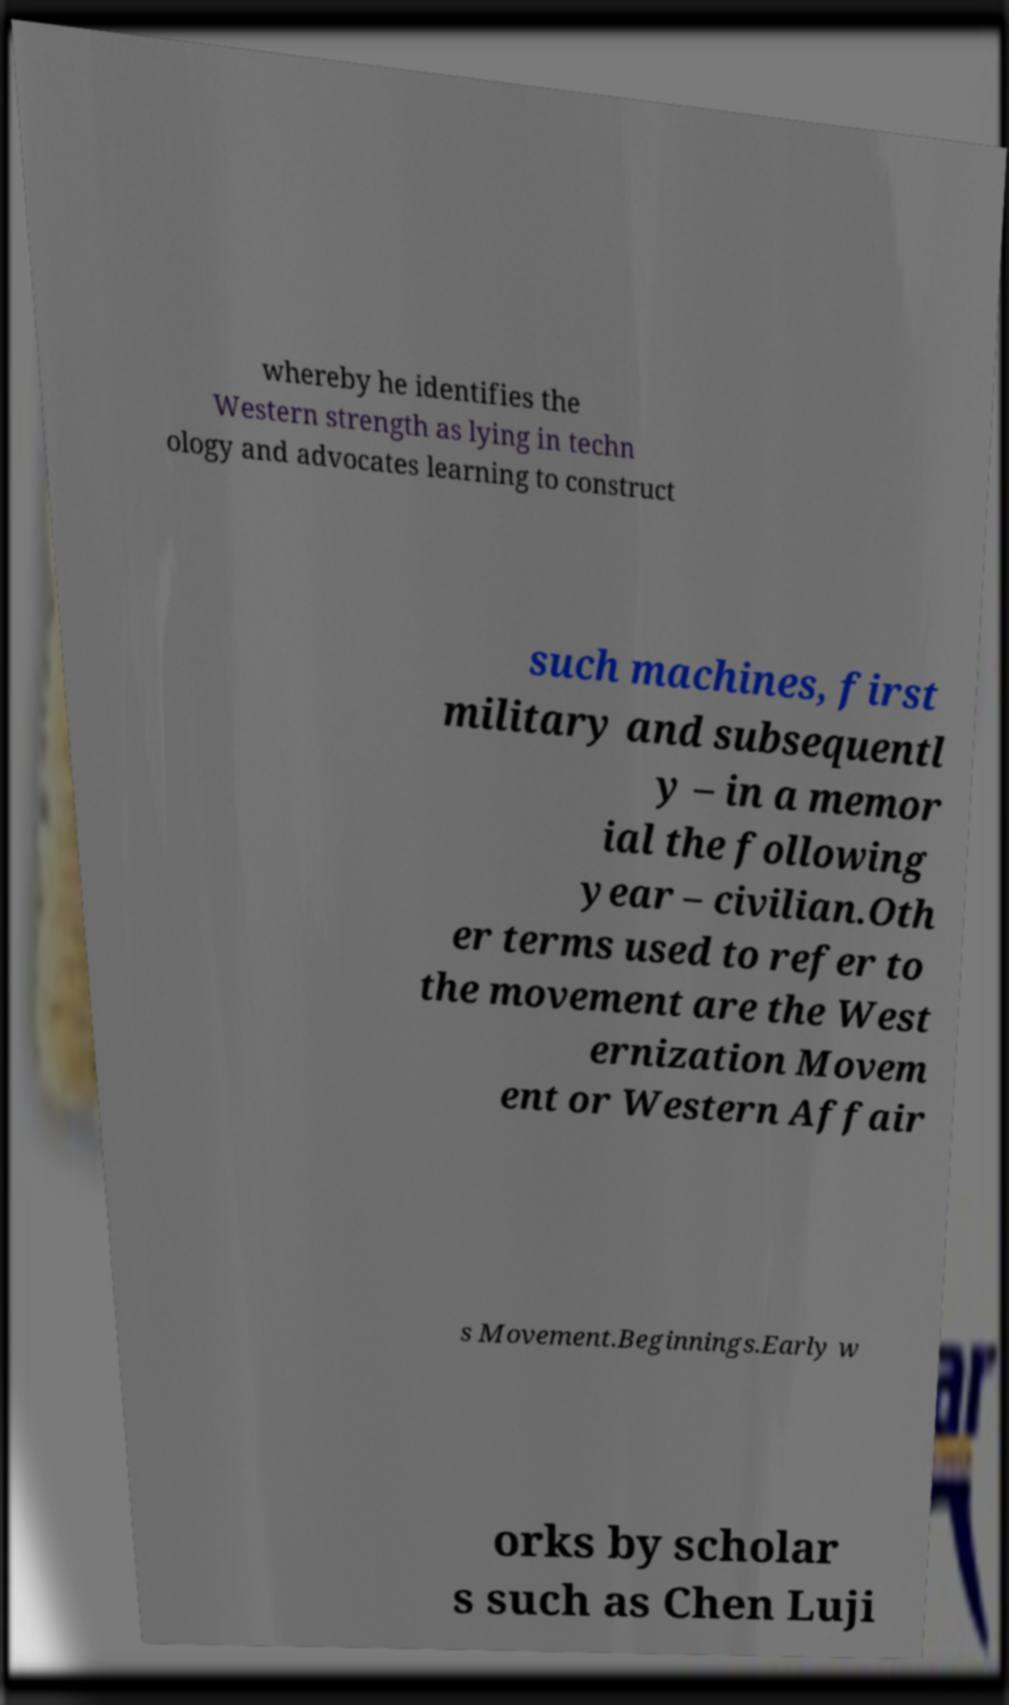Could you extract and type out the text from this image? whereby he identifies the Western strength as lying in techn ology and advocates learning to construct such machines, first military and subsequentl y – in a memor ial the following year – civilian.Oth er terms used to refer to the movement are the West ernization Movem ent or Western Affair s Movement.Beginnings.Early w orks by scholar s such as Chen Luji 